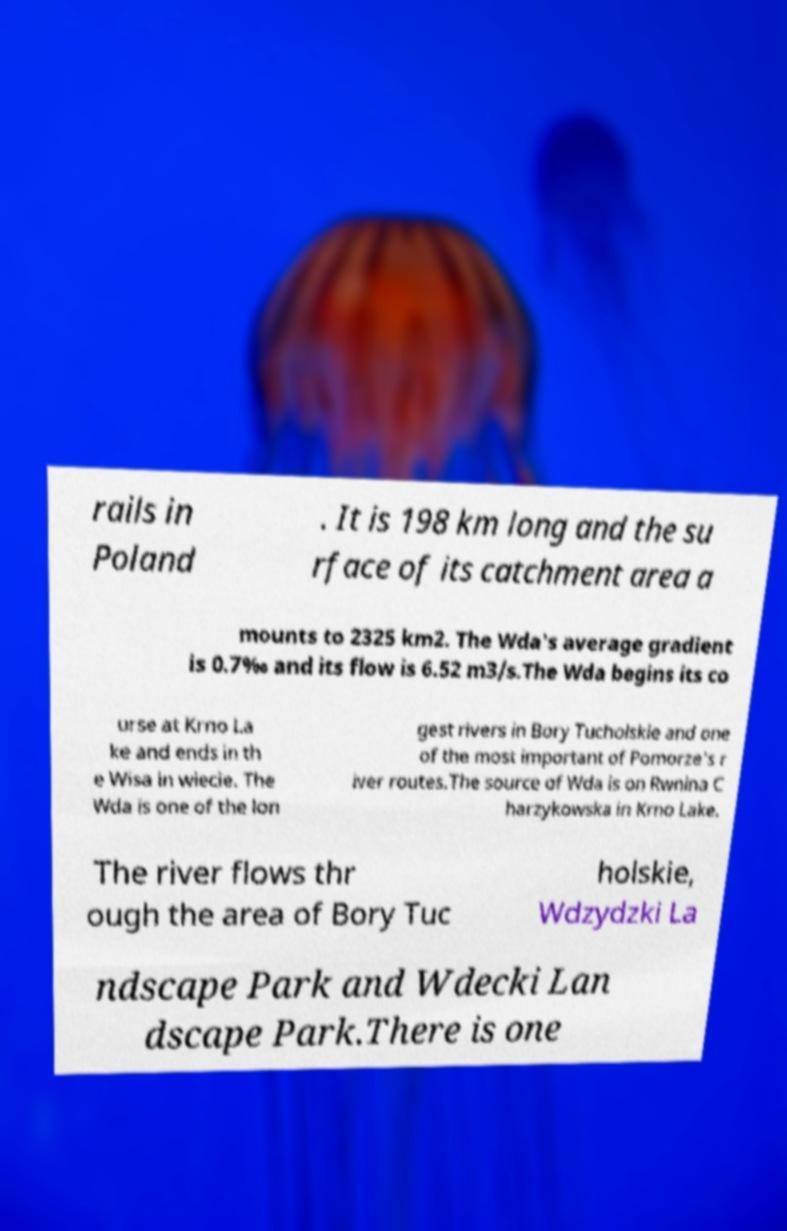There's text embedded in this image that I need extracted. Can you transcribe it verbatim? rails in Poland . It is 198 km long and the su rface of its catchment area a mounts to 2325 km2. The Wda's average gradient is 0.7‰ and its flow is 6.52 m3/s.The Wda begins its co urse at Krno La ke and ends in th e Wisa in wiecie. The Wda is one of the lon gest rivers in Bory Tucholskie and one of the most important of Pomorze's r iver routes.The source of Wda is on Rwnina C harzykowska in Krno Lake. The river flows thr ough the area of Bory Tuc holskie, Wdzydzki La ndscape Park and Wdecki Lan dscape Park.There is one 